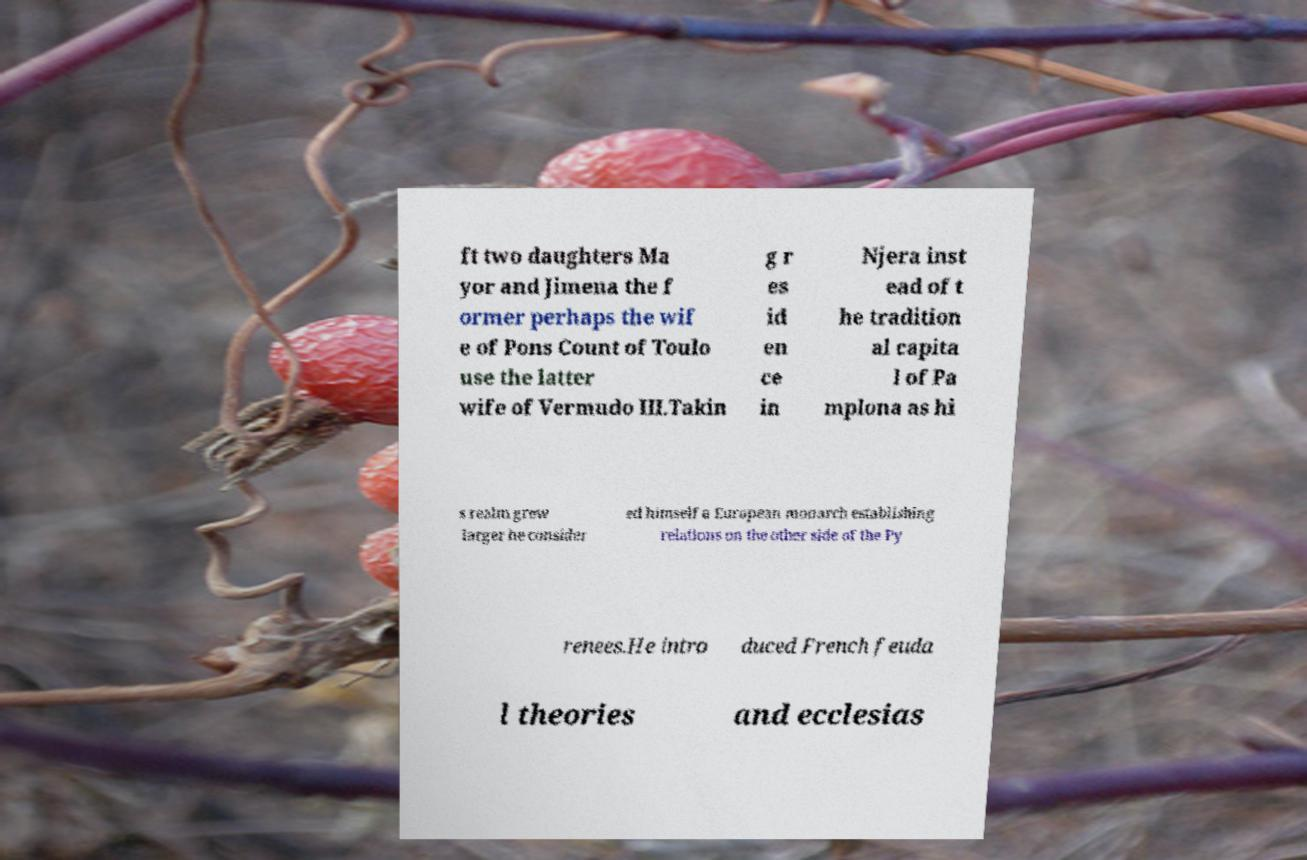Could you extract and type out the text from this image? ft two daughters Ma yor and Jimena the f ormer perhaps the wif e of Pons Count of Toulo use the latter wife of Vermudo III.Takin g r es id en ce in Njera inst ead of t he tradition al capita l of Pa mplona as hi s realm grew larger he consider ed himself a European monarch establishing relations on the other side of the Py renees.He intro duced French feuda l theories and ecclesias 